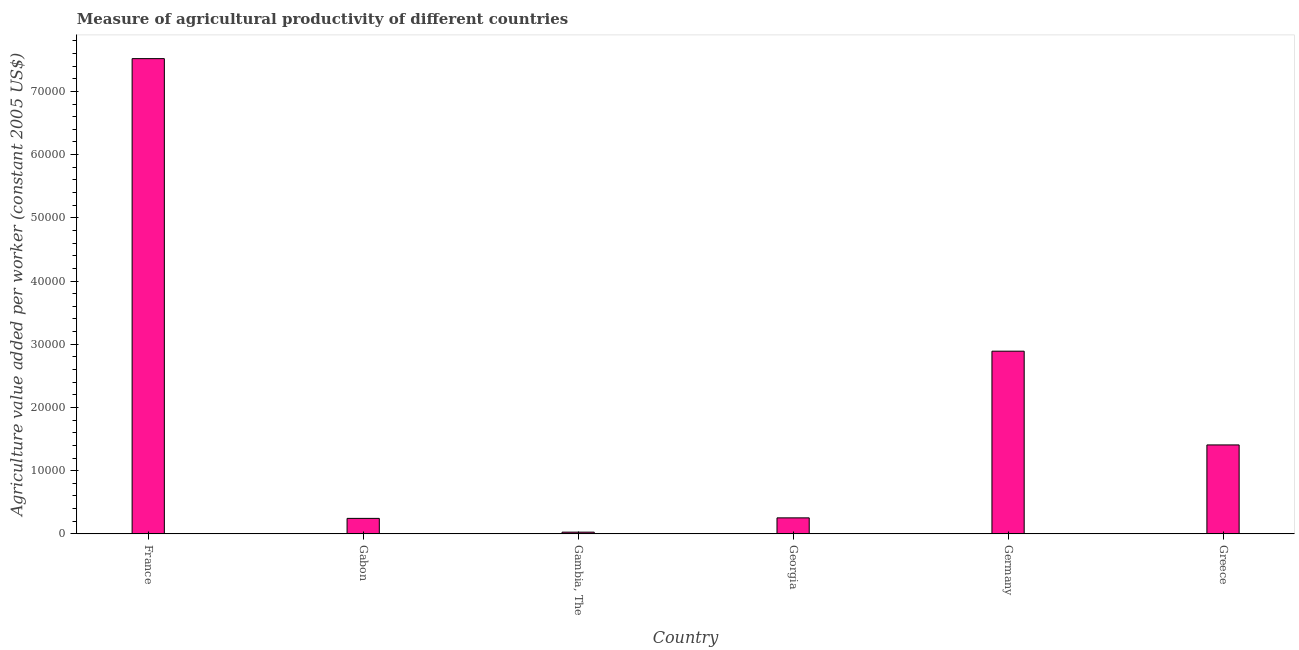Does the graph contain grids?
Ensure brevity in your answer.  No. What is the title of the graph?
Keep it short and to the point. Measure of agricultural productivity of different countries. What is the label or title of the Y-axis?
Ensure brevity in your answer.  Agriculture value added per worker (constant 2005 US$). What is the agriculture value added per worker in Gambia, The?
Your response must be concise. 270.3. Across all countries, what is the maximum agriculture value added per worker?
Ensure brevity in your answer.  7.52e+04. Across all countries, what is the minimum agriculture value added per worker?
Provide a succinct answer. 270.3. In which country was the agriculture value added per worker maximum?
Your response must be concise. France. In which country was the agriculture value added per worker minimum?
Your answer should be compact. Gambia, The. What is the sum of the agriculture value added per worker?
Your answer should be very brief. 1.23e+05. What is the difference between the agriculture value added per worker in Georgia and Greece?
Offer a terse response. -1.15e+04. What is the average agriculture value added per worker per country?
Offer a terse response. 2.06e+04. What is the median agriculture value added per worker?
Offer a terse response. 8300.13. What is the ratio of the agriculture value added per worker in France to that in Greece?
Your answer should be compact. 5.34. Is the agriculture value added per worker in Gabon less than that in Germany?
Offer a very short reply. Yes. What is the difference between the highest and the second highest agriculture value added per worker?
Give a very brief answer. 4.63e+04. What is the difference between the highest and the lowest agriculture value added per worker?
Provide a short and direct response. 7.49e+04. In how many countries, is the agriculture value added per worker greater than the average agriculture value added per worker taken over all countries?
Make the answer very short. 2. How many bars are there?
Your response must be concise. 6. Are all the bars in the graph horizontal?
Your answer should be very brief. No. What is the difference between two consecutive major ticks on the Y-axis?
Your response must be concise. 10000. What is the Agriculture value added per worker (constant 2005 US$) of France?
Your answer should be very brief. 7.52e+04. What is the Agriculture value added per worker (constant 2005 US$) of Gabon?
Make the answer very short. 2447.8. What is the Agriculture value added per worker (constant 2005 US$) of Gambia, The?
Keep it short and to the point. 270.3. What is the Agriculture value added per worker (constant 2005 US$) in Georgia?
Offer a very short reply. 2531.04. What is the Agriculture value added per worker (constant 2005 US$) of Germany?
Your answer should be compact. 2.89e+04. What is the Agriculture value added per worker (constant 2005 US$) of Greece?
Your answer should be very brief. 1.41e+04. What is the difference between the Agriculture value added per worker (constant 2005 US$) in France and Gabon?
Keep it short and to the point. 7.27e+04. What is the difference between the Agriculture value added per worker (constant 2005 US$) in France and Gambia, The?
Your answer should be very brief. 7.49e+04. What is the difference between the Agriculture value added per worker (constant 2005 US$) in France and Georgia?
Your response must be concise. 7.27e+04. What is the difference between the Agriculture value added per worker (constant 2005 US$) in France and Germany?
Your answer should be very brief. 4.63e+04. What is the difference between the Agriculture value added per worker (constant 2005 US$) in France and Greece?
Your response must be concise. 6.11e+04. What is the difference between the Agriculture value added per worker (constant 2005 US$) in Gabon and Gambia, The?
Provide a succinct answer. 2177.5. What is the difference between the Agriculture value added per worker (constant 2005 US$) in Gabon and Georgia?
Provide a succinct answer. -83.24. What is the difference between the Agriculture value added per worker (constant 2005 US$) in Gabon and Germany?
Your answer should be very brief. -2.65e+04. What is the difference between the Agriculture value added per worker (constant 2005 US$) in Gabon and Greece?
Ensure brevity in your answer.  -1.16e+04. What is the difference between the Agriculture value added per worker (constant 2005 US$) in Gambia, The and Georgia?
Your response must be concise. -2260.74. What is the difference between the Agriculture value added per worker (constant 2005 US$) in Gambia, The and Germany?
Offer a terse response. -2.86e+04. What is the difference between the Agriculture value added per worker (constant 2005 US$) in Gambia, The and Greece?
Offer a terse response. -1.38e+04. What is the difference between the Agriculture value added per worker (constant 2005 US$) in Georgia and Germany?
Provide a short and direct response. -2.64e+04. What is the difference between the Agriculture value added per worker (constant 2005 US$) in Georgia and Greece?
Make the answer very short. -1.15e+04. What is the difference between the Agriculture value added per worker (constant 2005 US$) in Germany and Greece?
Offer a very short reply. 1.48e+04. What is the ratio of the Agriculture value added per worker (constant 2005 US$) in France to that in Gabon?
Your response must be concise. 30.71. What is the ratio of the Agriculture value added per worker (constant 2005 US$) in France to that in Gambia, The?
Provide a short and direct response. 278.14. What is the ratio of the Agriculture value added per worker (constant 2005 US$) in France to that in Georgia?
Offer a very short reply. 29.7. What is the ratio of the Agriculture value added per worker (constant 2005 US$) in France to that in Germany?
Provide a succinct answer. 2.6. What is the ratio of the Agriculture value added per worker (constant 2005 US$) in France to that in Greece?
Provide a succinct answer. 5.34. What is the ratio of the Agriculture value added per worker (constant 2005 US$) in Gabon to that in Gambia, The?
Keep it short and to the point. 9.06. What is the ratio of the Agriculture value added per worker (constant 2005 US$) in Gabon to that in Georgia?
Offer a very short reply. 0.97. What is the ratio of the Agriculture value added per worker (constant 2005 US$) in Gabon to that in Germany?
Your answer should be very brief. 0.09. What is the ratio of the Agriculture value added per worker (constant 2005 US$) in Gabon to that in Greece?
Ensure brevity in your answer.  0.17. What is the ratio of the Agriculture value added per worker (constant 2005 US$) in Gambia, The to that in Georgia?
Give a very brief answer. 0.11. What is the ratio of the Agriculture value added per worker (constant 2005 US$) in Gambia, The to that in Germany?
Give a very brief answer. 0.01. What is the ratio of the Agriculture value added per worker (constant 2005 US$) in Gambia, The to that in Greece?
Your response must be concise. 0.02. What is the ratio of the Agriculture value added per worker (constant 2005 US$) in Georgia to that in Germany?
Keep it short and to the point. 0.09. What is the ratio of the Agriculture value added per worker (constant 2005 US$) in Georgia to that in Greece?
Give a very brief answer. 0.18. What is the ratio of the Agriculture value added per worker (constant 2005 US$) in Germany to that in Greece?
Your answer should be compact. 2.05. 